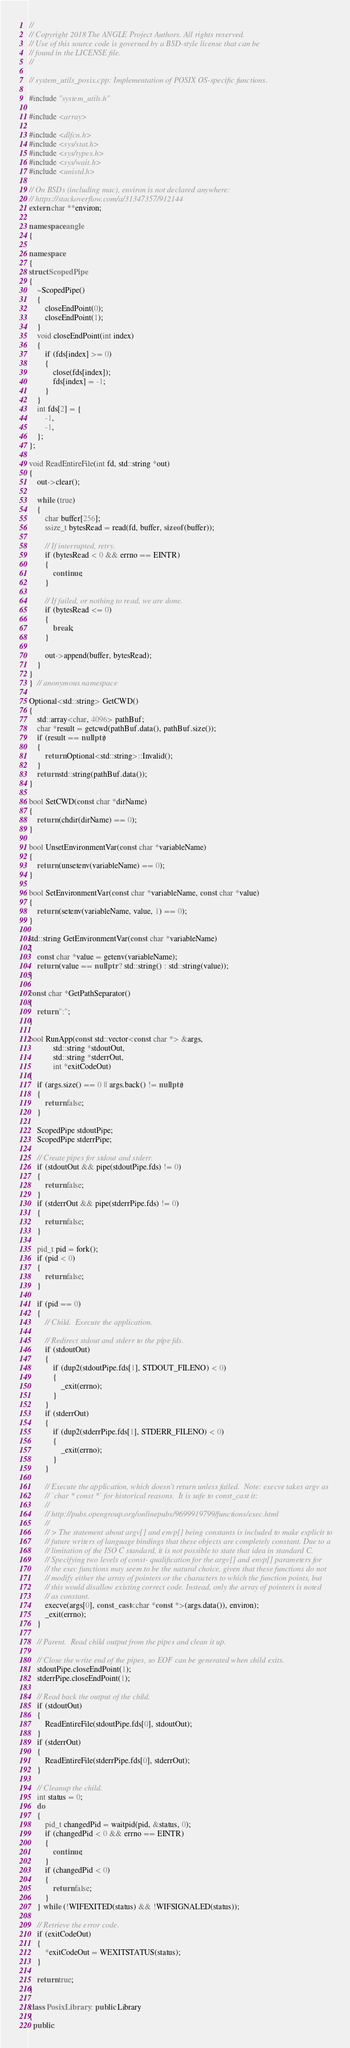<code> <loc_0><loc_0><loc_500><loc_500><_C++_>//
// Copyright 2018 The ANGLE Project Authors. All rights reserved.
// Use of this source code is governed by a BSD-style license that can be
// found in the LICENSE file.
//

// system_utils_posix.cpp: Implementation of POSIX OS-specific functions.

#include "system_utils.h"

#include <array>

#include <dlfcn.h>
#include <sys/stat.h>
#include <sys/types.h>
#include <sys/wait.h>
#include <unistd.h>

// On BSDs (including mac), environ is not declared anywhere:
// https://stackoverflow.com/a/31347357/912144
extern char **environ;

namespace angle
{

namespace
{
struct ScopedPipe
{
    ~ScopedPipe()
    {
        closeEndPoint(0);
        closeEndPoint(1);
    }
    void closeEndPoint(int index)
    {
        if (fds[index] >= 0)
        {
            close(fds[index]);
            fds[index] = -1;
        }
    }
    int fds[2] = {
        -1,
        -1,
    };
};

void ReadEntireFile(int fd, std::string *out)
{
    out->clear();

    while (true)
    {
        char buffer[256];
        ssize_t bytesRead = read(fd, buffer, sizeof(buffer));

        // If interrupted, retry.
        if (bytesRead < 0 && errno == EINTR)
        {
            continue;
        }

        // If failed, or nothing to read, we are done.
        if (bytesRead <= 0)
        {
            break;
        }

        out->append(buffer, bytesRead);
    }
}
}  // anonymous namespace

Optional<std::string> GetCWD()
{
    std::array<char, 4096> pathBuf;
    char *result = getcwd(pathBuf.data(), pathBuf.size());
    if (result == nullptr)
    {
        return Optional<std::string>::Invalid();
    }
    return std::string(pathBuf.data());
}

bool SetCWD(const char *dirName)
{
    return (chdir(dirName) == 0);
}

bool UnsetEnvironmentVar(const char *variableName)
{
    return (unsetenv(variableName) == 0);
}

bool SetEnvironmentVar(const char *variableName, const char *value)
{
    return (setenv(variableName, value, 1) == 0);
}

std::string GetEnvironmentVar(const char *variableName)
{
    const char *value = getenv(variableName);
    return (value == nullptr ? std::string() : std::string(value));
}

const char *GetPathSeparator()
{
    return ":";
}

bool RunApp(const std::vector<const char *> &args,
            std::string *stdoutOut,
            std::string *stderrOut,
            int *exitCodeOut)
{
    if (args.size() == 0 || args.back() != nullptr)
    {
        return false;
    }

    ScopedPipe stdoutPipe;
    ScopedPipe stderrPipe;

    // Create pipes for stdout and stderr.
    if (stdoutOut && pipe(stdoutPipe.fds) != 0)
    {
        return false;
    }
    if (stderrOut && pipe(stderrPipe.fds) != 0)
    {
        return false;
    }

    pid_t pid = fork();
    if (pid < 0)
    {
        return false;
    }

    if (pid == 0)
    {
        // Child.  Execute the application.

        // Redirect stdout and stderr to the pipe fds.
        if (stdoutOut)
        {
            if (dup2(stdoutPipe.fds[1], STDOUT_FILENO) < 0)
            {
                _exit(errno);
            }
        }
        if (stderrOut)
        {
            if (dup2(stderrPipe.fds[1], STDERR_FILENO) < 0)
            {
                _exit(errno);
            }
        }

        // Execute the application, which doesn't return unless failed.  Note: execve takes argv as
        // `char * const *` for historical reasons.  It is safe to const_cast it:
        //
        // http://pubs.opengroup.org/onlinepubs/9699919799/functions/exec.html
        //
        // > The statement about argv[] and envp[] being constants is included to make explicit to
        // future writers of language bindings that these objects are completely constant. Due to a
        // limitation of the ISO C standard, it is not possible to state that idea in standard C.
        // Specifying two levels of const- qualification for the argv[] and envp[] parameters for
        // the exec functions may seem to be the natural choice, given that these functions do not
        // modify either the array of pointers or the characters to which the function points, but
        // this would disallow existing correct code. Instead, only the array of pointers is noted
        // as constant.
        execve(args[0], const_cast<char *const *>(args.data()), environ);
        _exit(errno);
    }

    // Parent.  Read child output from the pipes and clean it up.

    // Close the write end of the pipes, so EOF can be generated when child exits.
    stdoutPipe.closeEndPoint(1);
    stderrPipe.closeEndPoint(1);

    // Read back the output of the child.
    if (stdoutOut)
    {
        ReadEntireFile(stdoutPipe.fds[0], stdoutOut);
    }
    if (stderrOut)
    {
        ReadEntireFile(stderrPipe.fds[0], stderrOut);
    }

    // Cleanup the child.
    int status = 0;
    do
    {
        pid_t changedPid = waitpid(pid, &status, 0);
        if (changedPid < 0 && errno == EINTR)
        {
            continue;
        }
        if (changedPid < 0)
        {
            return false;
        }
    } while (!WIFEXITED(status) && !WIFSIGNALED(status));

    // Retrieve the error code.
    if (exitCodeOut)
    {
        *exitCodeOut = WEXITSTATUS(status);
    }

    return true;
}

class PosixLibrary : public Library
{
  public:</code> 